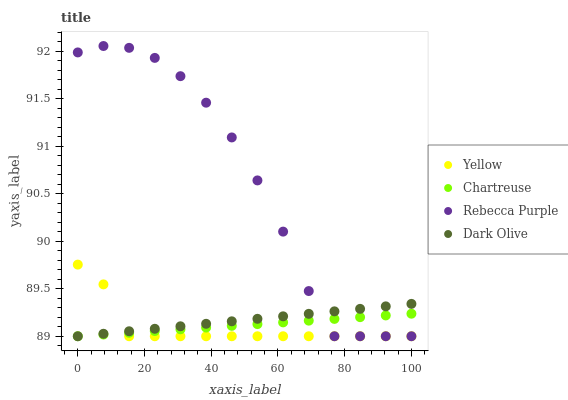Does Yellow have the minimum area under the curve?
Answer yes or no. Yes. Does Rebecca Purple have the maximum area under the curve?
Answer yes or no. Yes. Does Dark Olive have the minimum area under the curve?
Answer yes or no. No. Does Dark Olive have the maximum area under the curve?
Answer yes or no. No. Is Chartreuse the smoothest?
Answer yes or no. Yes. Is Rebecca Purple the roughest?
Answer yes or no. Yes. Is Dark Olive the smoothest?
Answer yes or no. No. Is Dark Olive the roughest?
Answer yes or no. No. Does Chartreuse have the lowest value?
Answer yes or no. Yes. Does Rebecca Purple have the highest value?
Answer yes or no. Yes. Does Dark Olive have the highest value?
Answer yes or no. No. Does Dark Olive intersect Yellow?
Answer yes or no. Yes. Is Dark Olive less than Yellow?
Answer yes or no. No. Is Dark Olive greater than Yellow?
Answer yes or no. No. 